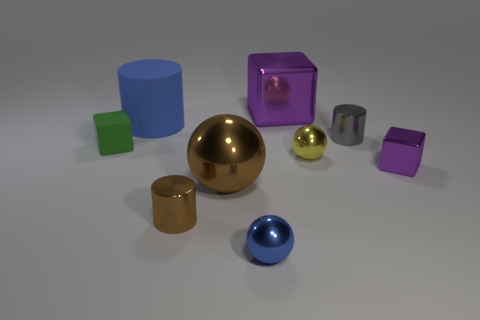Add 1 big cylinders. How many objects exist? 10 Subtract all spheres. How many objects are left? 6 Add 1 brown metallic spheres. How many brown metallic spheres are left? 2 Add 4 big spheres. How many big spheres exist? 5 Subtract 1 blue cylinders. How many objects are left? 8 Subtract all matte cylinders. Subtract all small things. How many objects are left? 2 